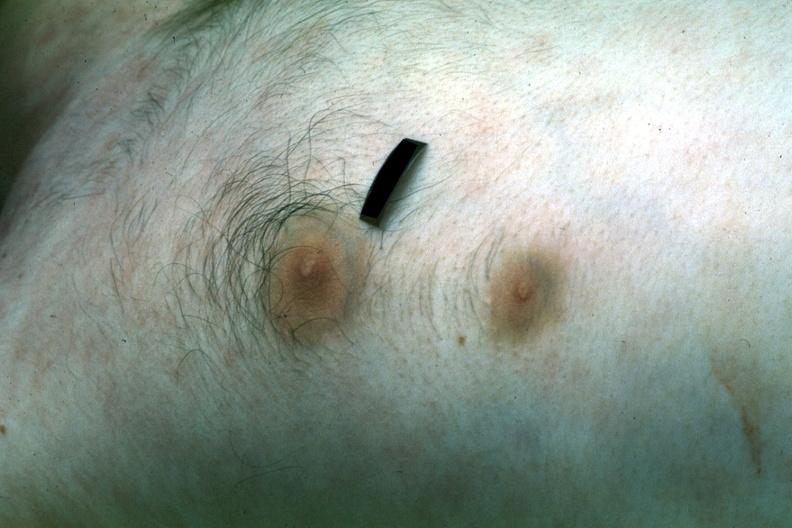how many nipples does this image show?
Answer the question using a single word or phrase. Two 